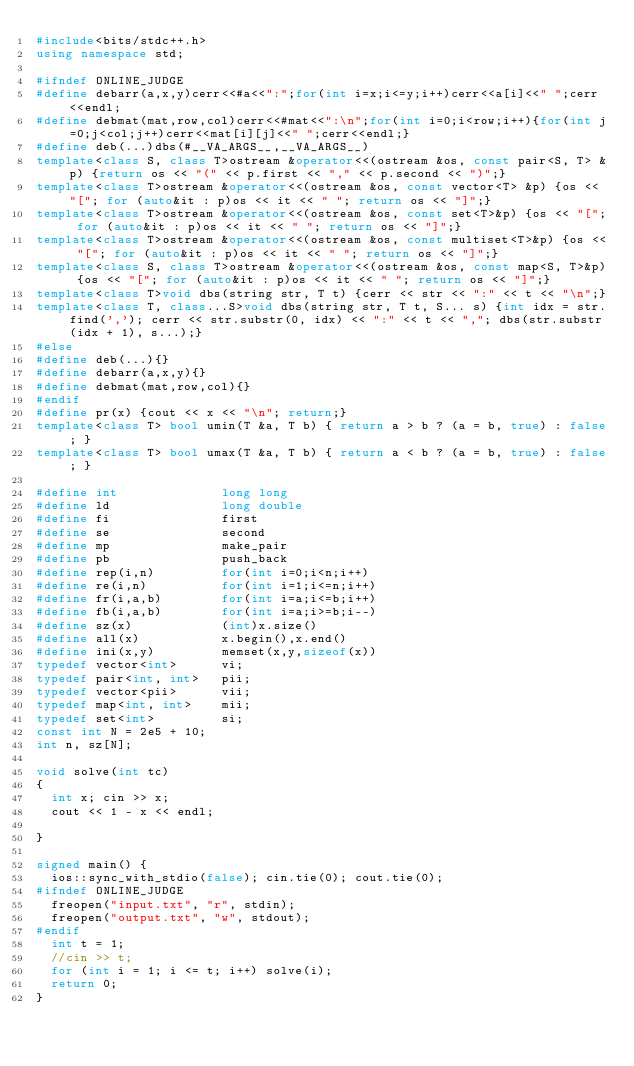Convert code to text. <code><loc_0><loc_0><loc_500><loc_500><_C++_>#include<bits/stdc++.h>
using namespace std;

#ifndef ONLINE_JUDGE
#define debarr(a,x,y)cerr<<#a<<":";for(int i=x;i<=y;i++)cerr<<a[i]<<" ";cerr<<endl;
#define debmat(mat,row,col)cerr<<#mat<<":\n";for(int i=0;i<row;i++){for(int j=0;j<col;j++)cerr<<mat[i][j]<<" ";cerr<<endl;}
#define deb(...)dbs(#__VA_ARGS__,__VA_ARGS__)
template<class S, class T>ostream &operator<<(ostream &os, const pair<S, T> &p) {return os << "(" << p.first << "," << p.second << ")";}
template<class T>ostream &operator<<(ostream &os, const vector<T> &p) {os << "["; for (auto&it : p)os << it << " "; return os << "]";}
template<class T>ostream &operator<<(ostream &os, const set<T>&p) {os << "["; for (auto&it : p)os << it << " "; return os << "]";}
template<class T>ostream &operator<<(ostream &os, const multiset<T>&p) {os << "["; for (auto&it : p)os << it << " "; return os << "]";}
template<class S, class T>ostream &operator<<(ostream &os, const map<S, T>&p) {os << "["; for (auto&it : p)os << it << " "; return os << "]";}
template<class T>void dbs(string str, T t) {cerr << str << ":" << t << "\n";}
template<class T, class...S>void dbs(string str, T t, S... s) {int idx = str.find(','); cerr << str.substr(0, idx) << ":" << t << ","; dbs(str.substr(idx + 1), s...);}
#else
#define deb(...){}
#define debarr(a,x,y){}
#define debmat(mat,row,col){}
#endif
#define pr(x) {cout << x << "\n"; return;}
template<class T> bool umin(T &a, T b) { return a > b ? (a = b, true) : false; }
template<class T> bool umax(T &a, T b) { return a < b ? (a = b, true) : false; }

#define int              long long
#define ld               long double
#define fi               first
#define se               second
#define mp               make_pair
#define pb               push_back
#define rep(i,n)         for(int i=0;i<n;i++)
#define re(i,n)          for(int i=1;i<=n;i++)
#define fr(i,a,b)        for(int i=a;i<=b;i++)
#define fb(i,a,b)        for(int i=a;i>=b;i--)
#define sz(x)            (int)x.size()
#define all(x)           x.begin(),x.end()
#define ini(x,y)         memset(x,y,sizeof(x))
typedef vector<int>      vi;
typedef pair<int, int>   pii;
typedef vector<pii>      vii;
typedef map<int, int>    mii;
typedef set<int>         si;
const int N = 2e5 + 10;
int n, sz[N];

void solve(int tc)
{
	int x; cin >> x;
	cout << 1 - x << endl;

}

signed main() {
	ios::sync_with_stdio(false); cin.tie(0); cout.tie(0);
#ifndef ONLINE_JUDGE
	freopen("input.txt", "r", stdin);
	freopen("output.txt", "w", stdout);
#endif
	int t = 1;
	//cin >> t;
	for (int i = 1; i <= t; i++) solve(i);
	return 0;
}</code> 